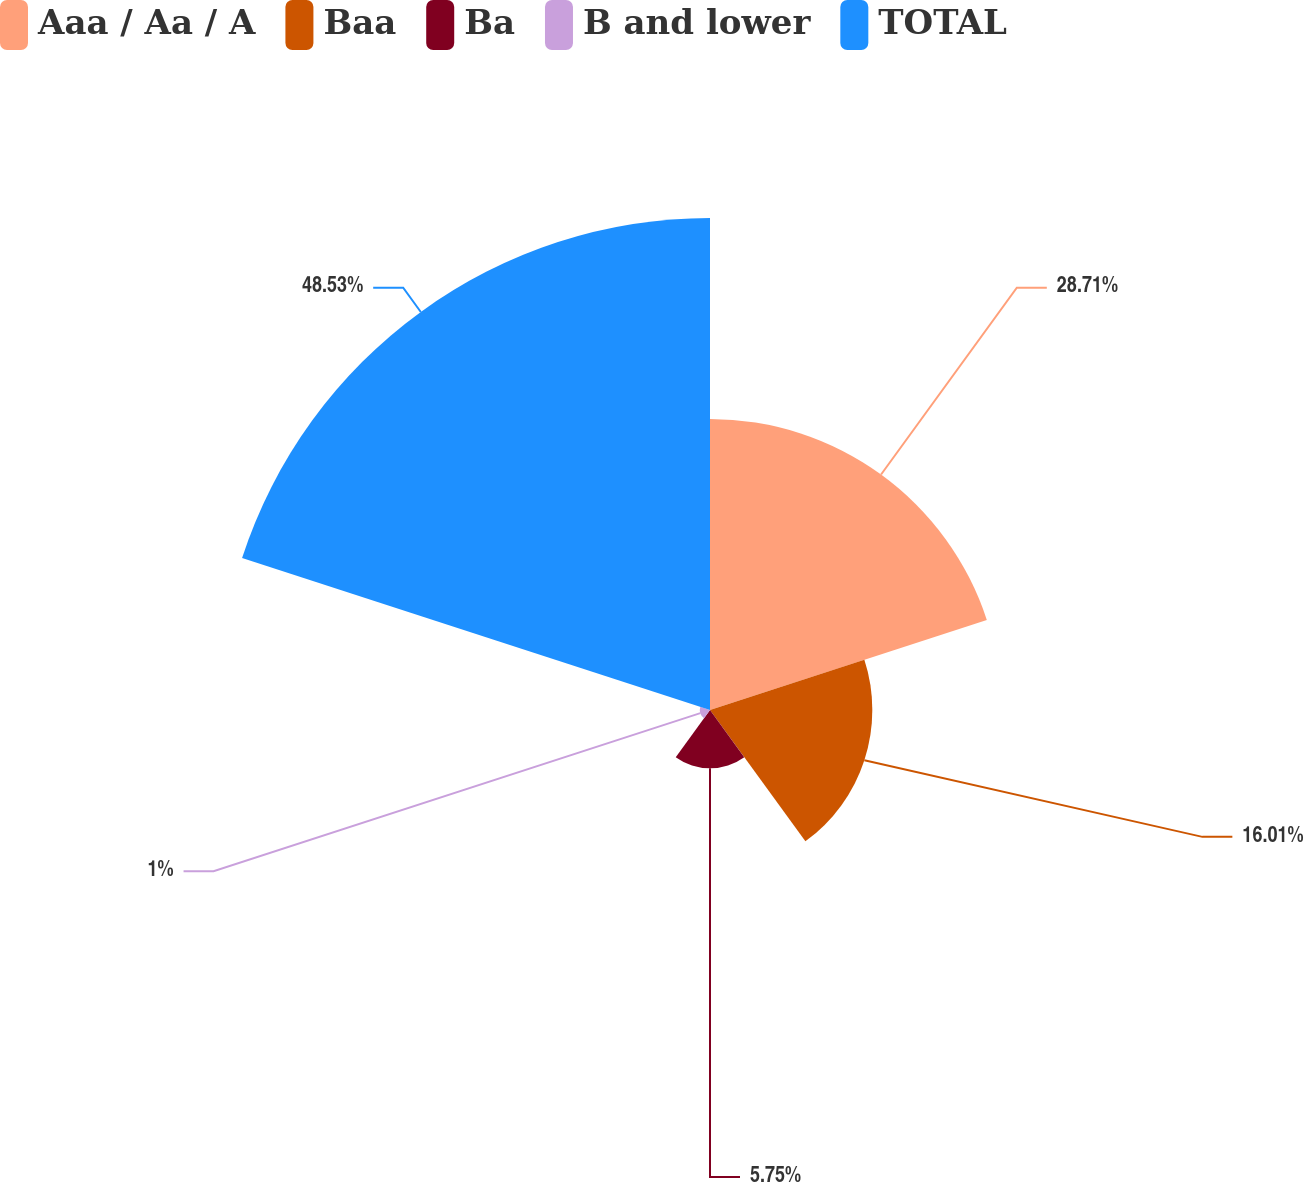<chart> <loc_0><loc_0><loc_500><loc_500><pie_chart><fcel>Aaa / Aa / A<fcel>Baa<fcel>Ba<fcel>B and lower<fcel>TOTAL<nl><fcel>28.71%<fcel>16.01%<fcel>5.75%<fcel>1.0%<fcel>48.53%<nl></chart> 